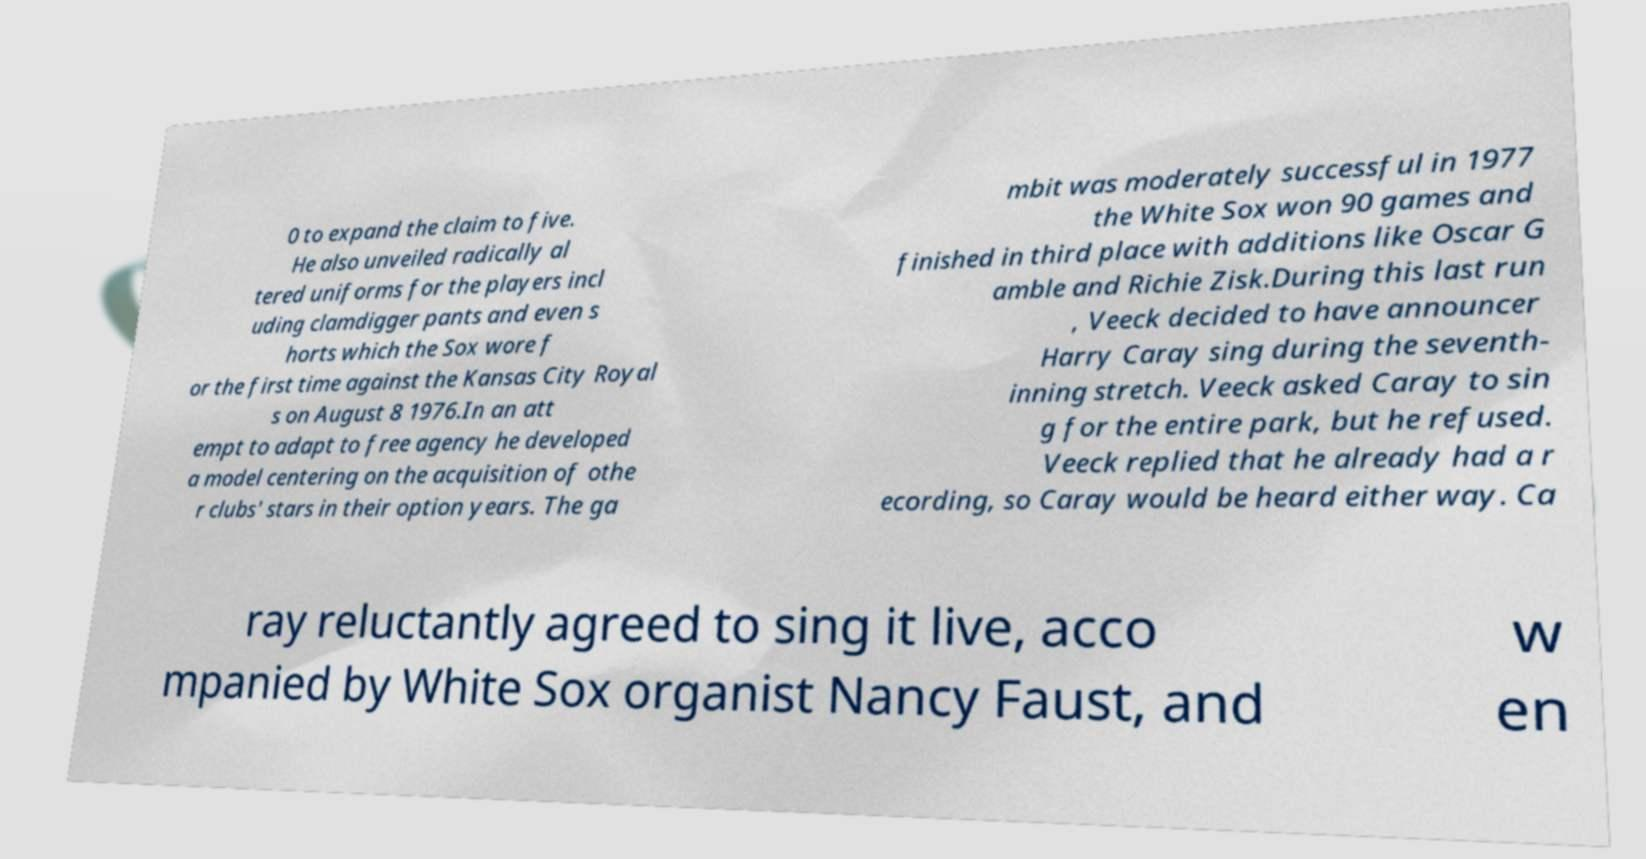Can you read and provide the text displayed in the image?This photo seems to have some interesting text. Can you extract and type it out for me? 0 to expand the claim to five. He also unveiled radically al tered uniforms for the players incl uding clamdigger pants and even s horts which the Sox wore f or the first time against the Kansas City Royal s on August 8 1976.In an att empt to adapt to free agency he developed a model centering on the acquisition of othe r clubs' stars in their option years. The ga mbit was moderately successful in 1977 the White Sox won 90 games and finished in third place with additions like Oscar G amble and Richie Zisk.During this last run , Veeck decided to have announcer Harry Caray sing during the seventh- inning stretch. Veeck asked Caray to sin g for the entire park, but he refused. Veeck replied that he already had a r ecording, so Caray would be heard either way. Ca ray reluctantly agreed to sing it live, acco mpanied by White Sox organist Nancy Faust, and w en 